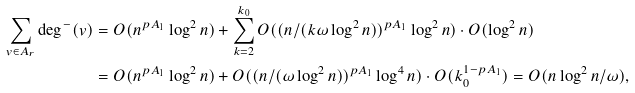<formula> <loc_0><loc_0><loc_500><loc_500>\sum _ { v \in A _ { r } } \deg ^ { - } ( v ) & = O ( n ^ { p A _ { 1 } } \log ^ { 2 } n ) + \sum _ { k = 2 } ^ { k _ { 0 } } O ( ( n / ( k \omega \log ^ { 2 } n ) ) ^ { p A _ { 1 } } \log ^ { 2 } n ) \cdot O ( \log ^ { 2 } n ) \\ & = O ( n ^ { p A _ { 1 } } \log ^ { 2 } n ) + O ( ( n / ( \omega \log ^ { 2 } n ) ) ^ { p A _ { 1 } } \log ^ { 4 } n ) \cdot O ( k _ { 0 } ^ { 1 - p A _ { 1 } } ) = O ( n \log ^ { 2 } n / \omega ) ,</formula> 